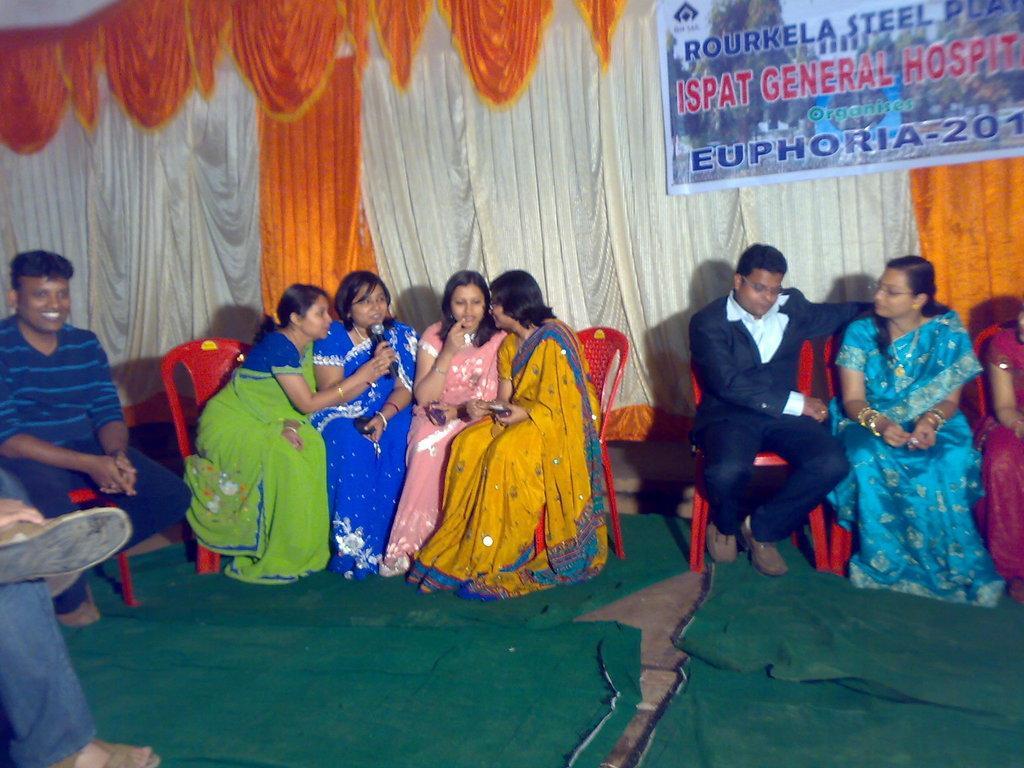In one or two sentences, can you explain what this image depicts? This image is taken outdoors. At the bottom of the image there is a floor with green carpets. In the background there are a few curtains and a banner with text on it. In the middle of the image a few women and three men are sitting on the chairs. 